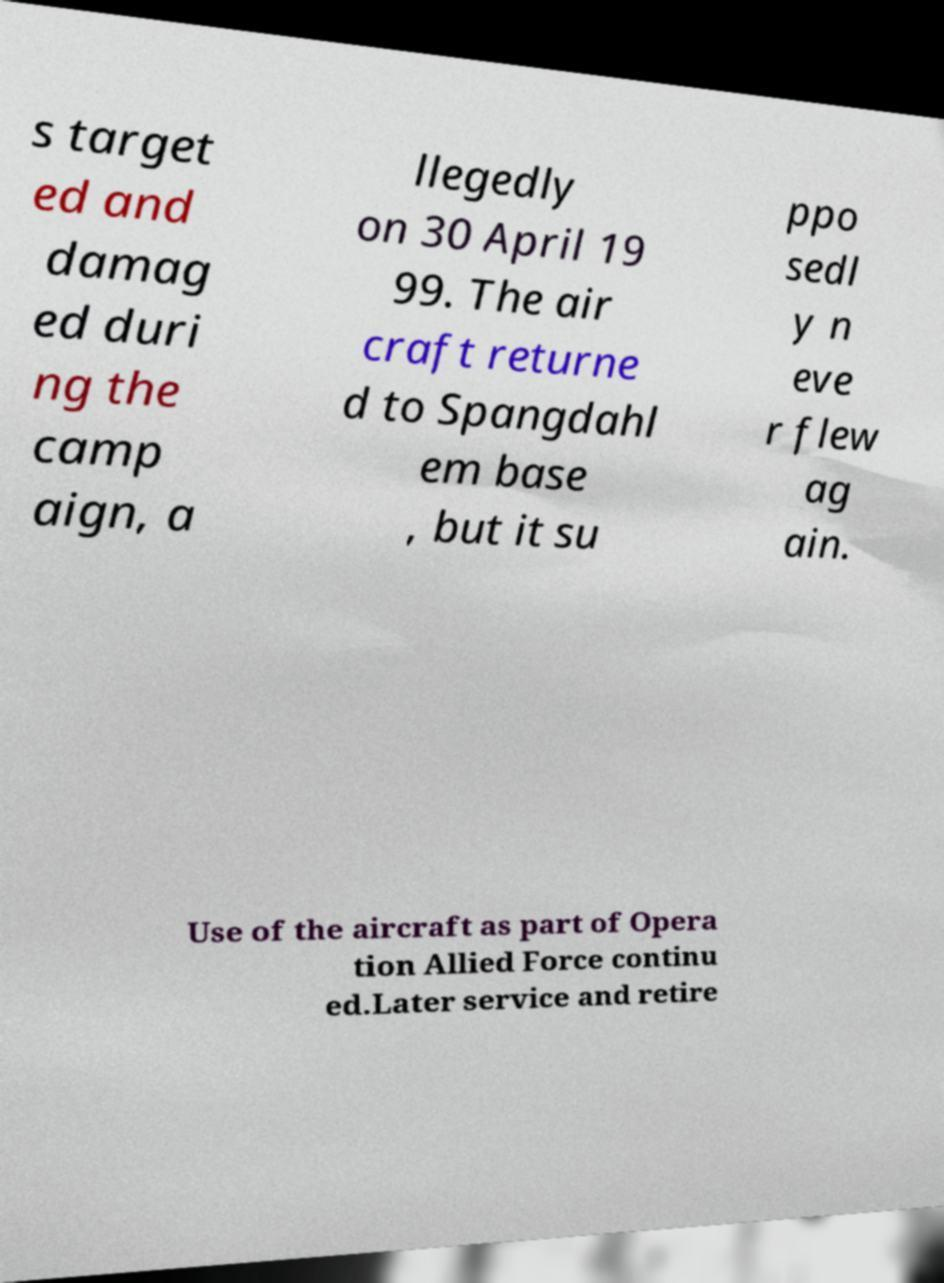Can you read and provide the text displayed in the image?This photo seems to have some interesting text. Can you extract and type it out for me? s target ed and damag ed duri ng the camp aign, a llegedly on 30 April 19 99. The air craft returne d to Spangdahl em base , but it su ppo sedl y n eve r flew ag ain. Use of the aircraft as part of Opera tion Allied Force continu ed.Later service and retire 